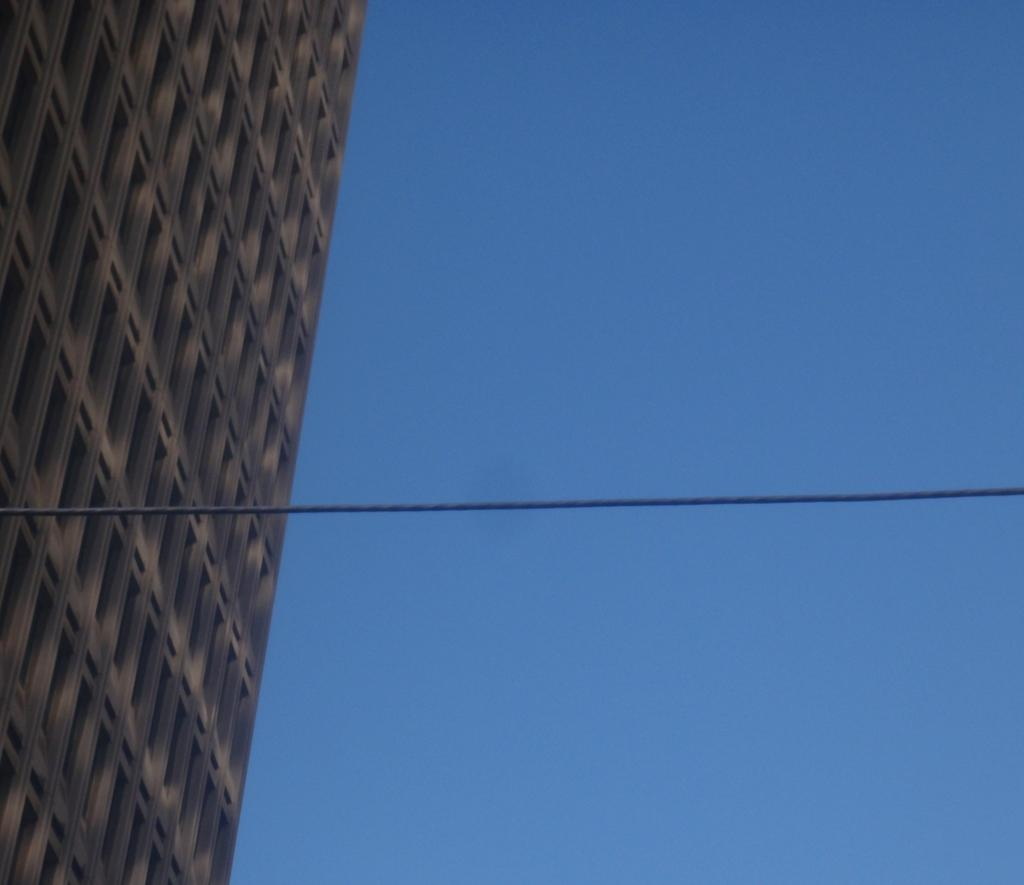What structure is located on the left side of the image? There is a building with windows on the left side of the image. What can be seen on the right side of the image? There is sky visible on the right side of the image. What object is in the middle of the image? There is a rope in the middle of the image. What type of suit is the mother wearing in the image? There is no mother or suit present in the image. Where is the middle of the image located? The middle of the image is between the left and right sides, and it contains the rope. 